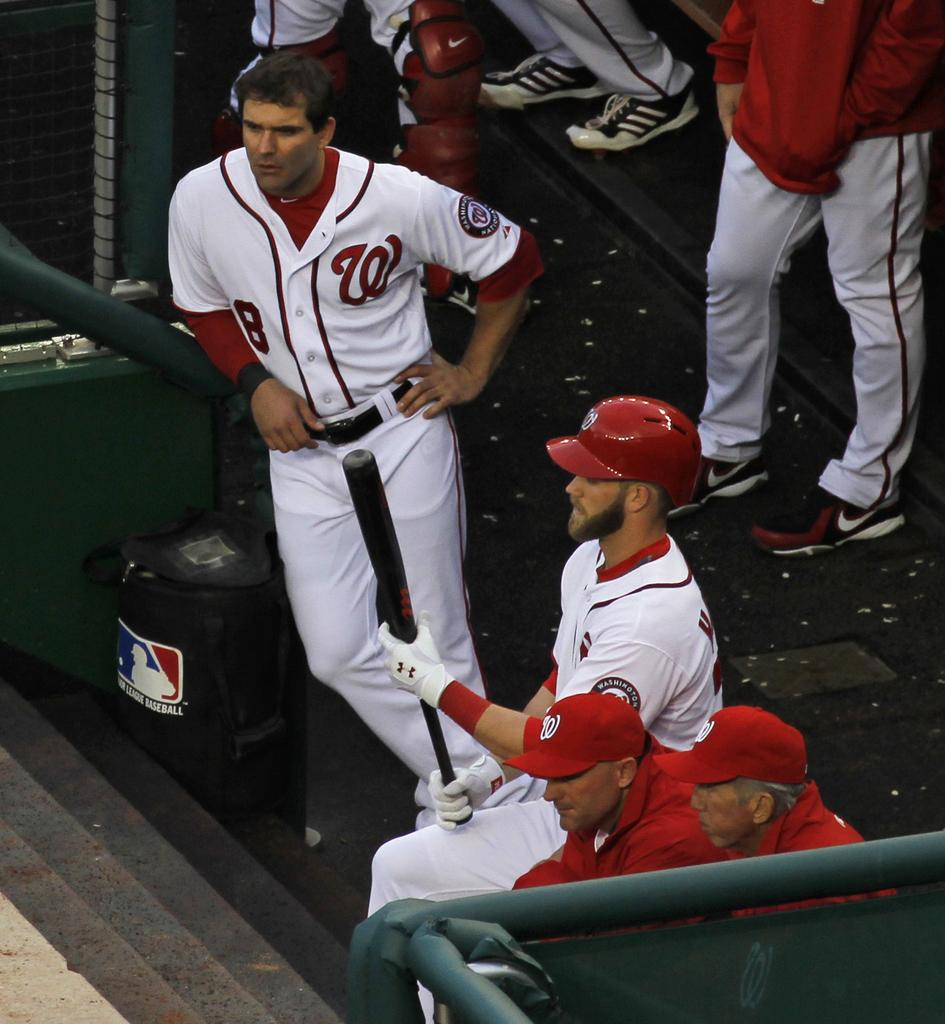<image>
Render a clear and concise summary of the photo. Washington National players sitting in the dugout ready to go to bat 